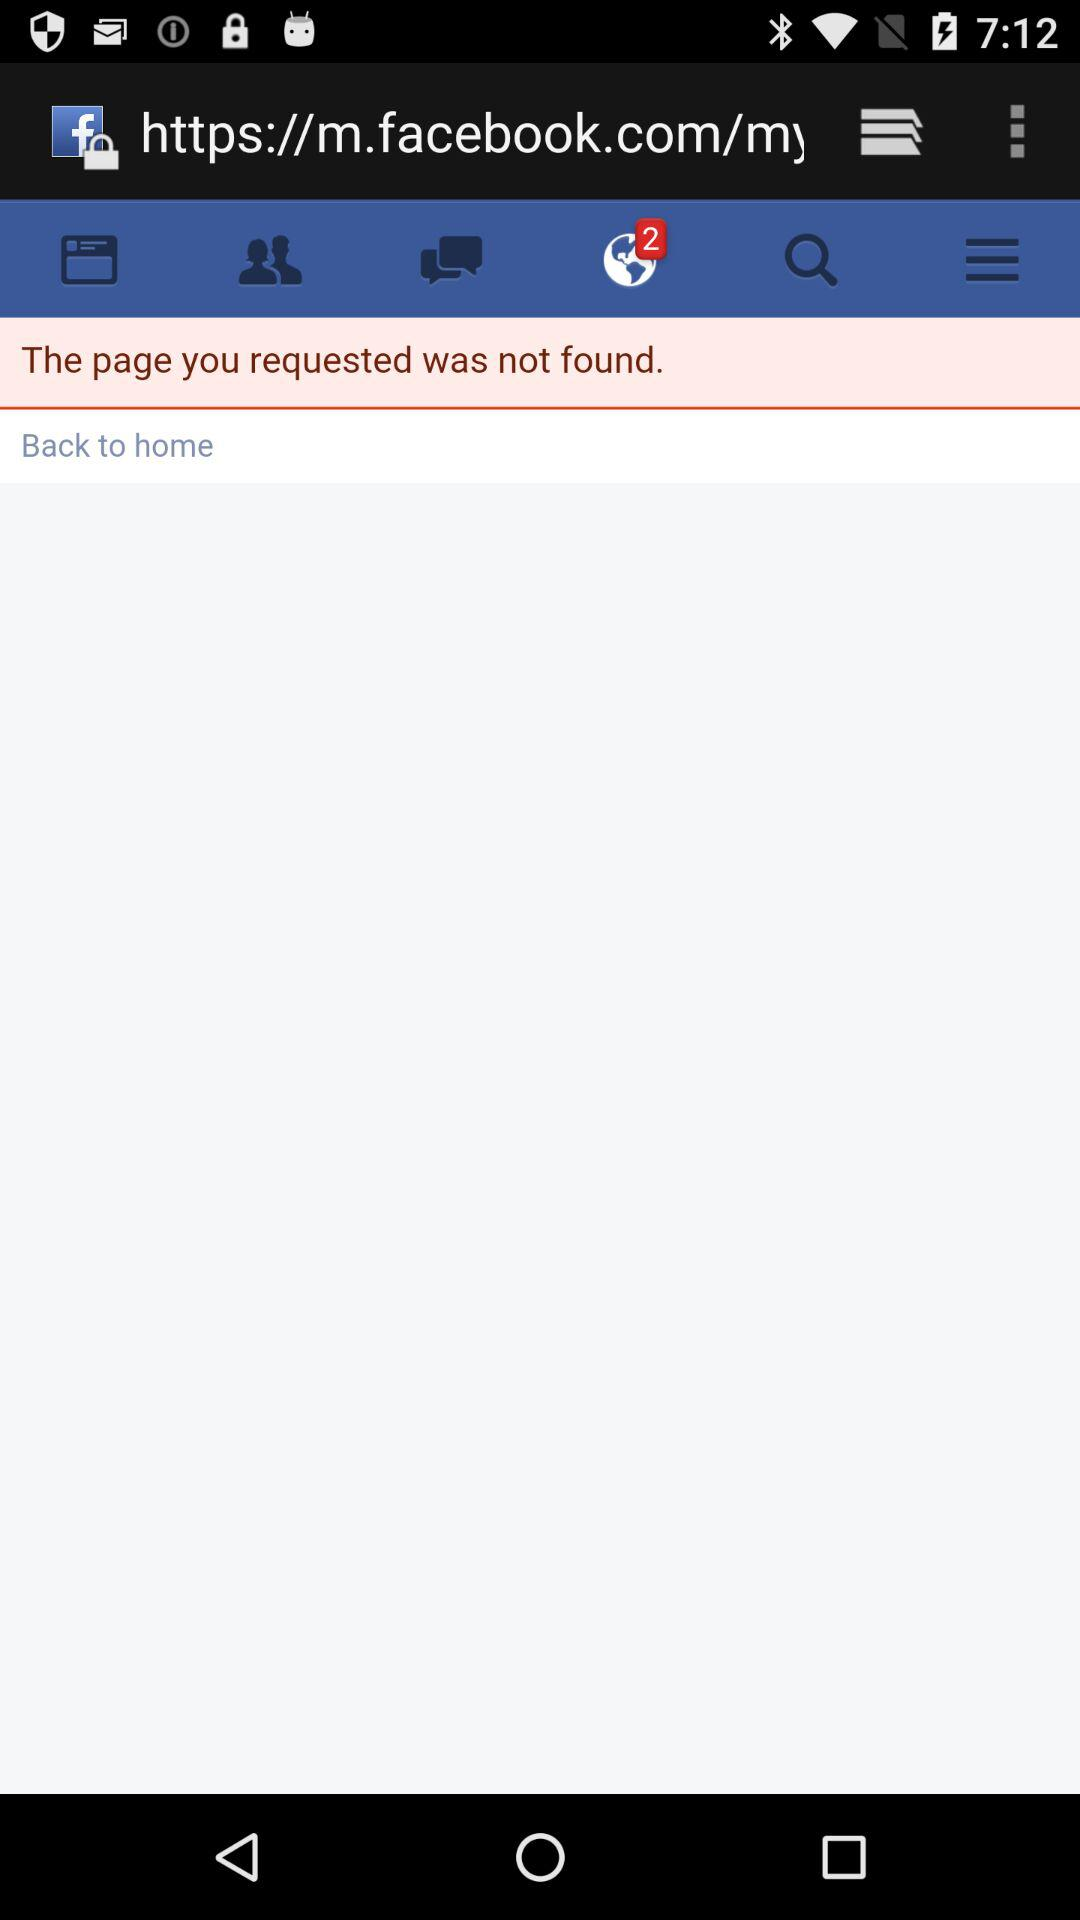What is the number of unread notifications? The number of unread notifications is 2. 